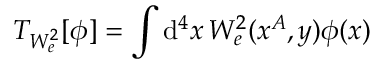<formula> <loc_0><loc_0><loc_500><loc_500>T _ { W _ { e } ^ { 2 } } [ \phi ] = \int d ^ { 4 } x \, W _ { e } ^ { 2 } ( x ^ { A } , y ) \phi ( x )</formula> 